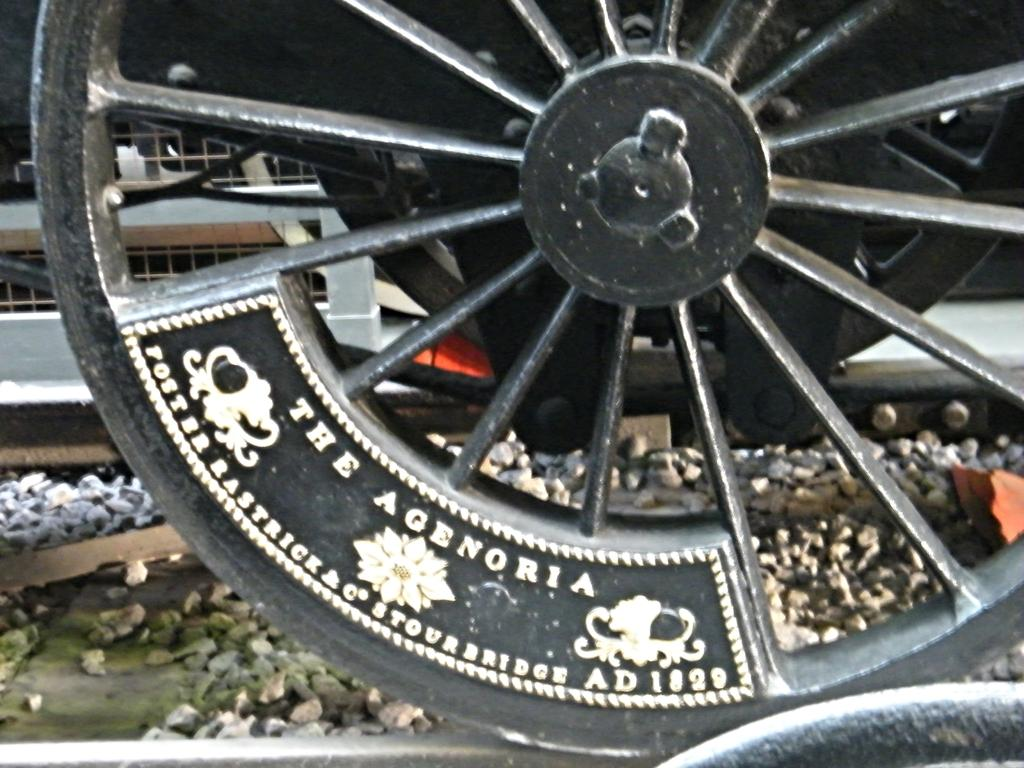Provide a one-sentence caption for the provided image. An old metal wheel with the words The Agenoria stamped on it. 